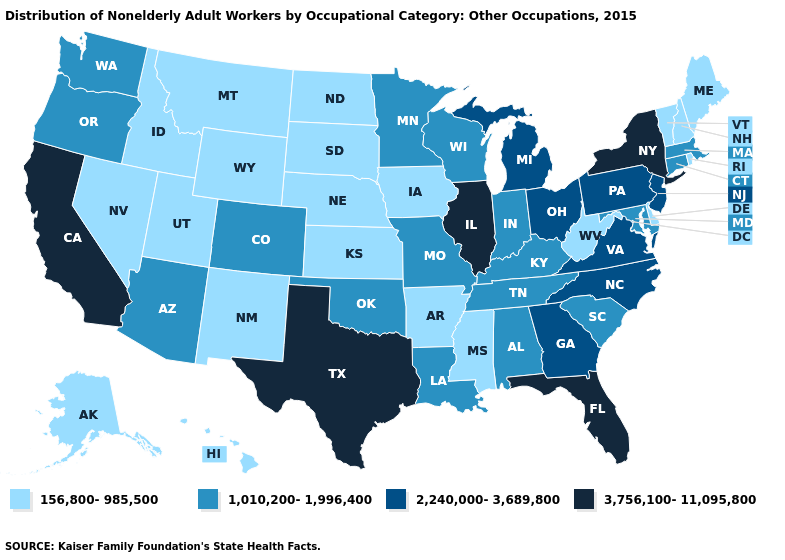What is the highest value in the USA?
Write a very short answer. 3,756,100-11,095,800. What is the value of Arizona?
Keep it brief. 1,010,200-1,996,400. Among the states that border Wisconsin , which have the highest value?
Be succinct. Illinois. What is the value of New Mexico?
Quick response, please. 156,800-985,500. What is the value of Illinois?
Give a very brief answer. 3,756,100-11,095,800. How many symbols are there in the legend?
Answer briefly. 4. Does California have the highest value in the West?
Keep it brief. Yes. Does New Hampshire have a lower value than New Mexico?
Short answer required. No. Among the states that border Maine , which have the highest value?
Short answer required. New Hampshire. What is the highest value in the USA?
Short answer required. 3,756,100-11,095,800. What is the highest value in the USA?
Write a very short answer. 3,756,100-11,095,800. What is the lowest value in states that border Tennessee?
Short answer required. 156,800-985,500. Does Texas have the highest value in the USA?
Write a very short answer. Yes. What is the lowest value in the MidWest?
Short answer required. 156,800-985,500. 